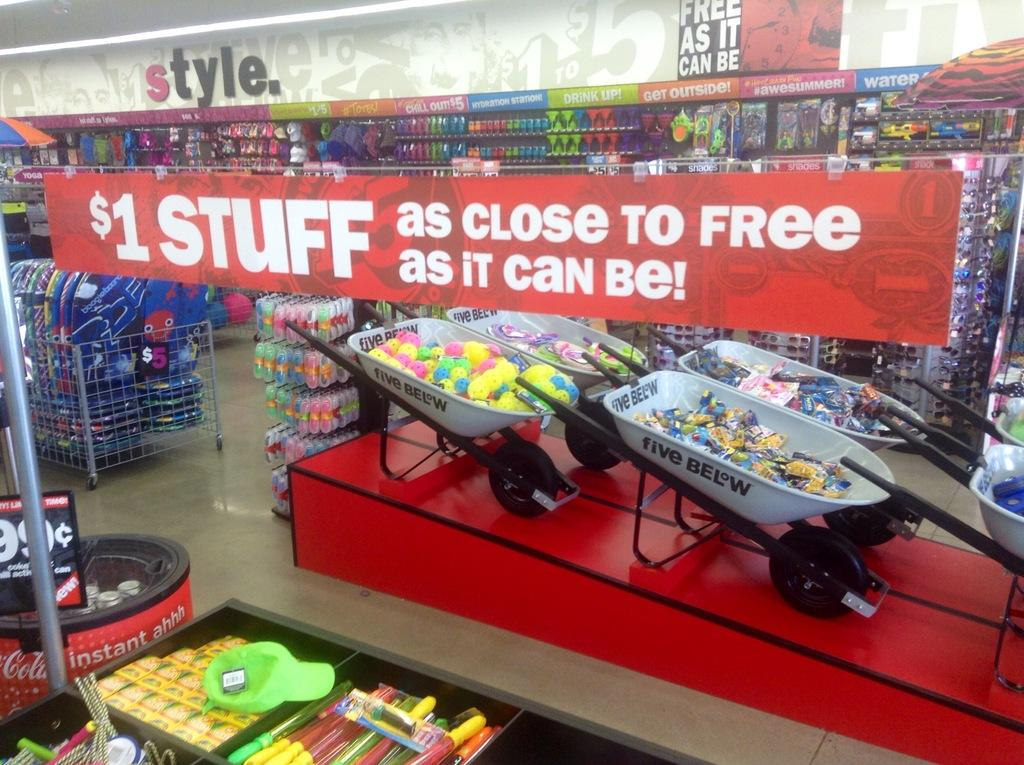<image>
Offer a succinct explanation of the picture presented. a sign for $1 STUFF over a sale display in a shop 